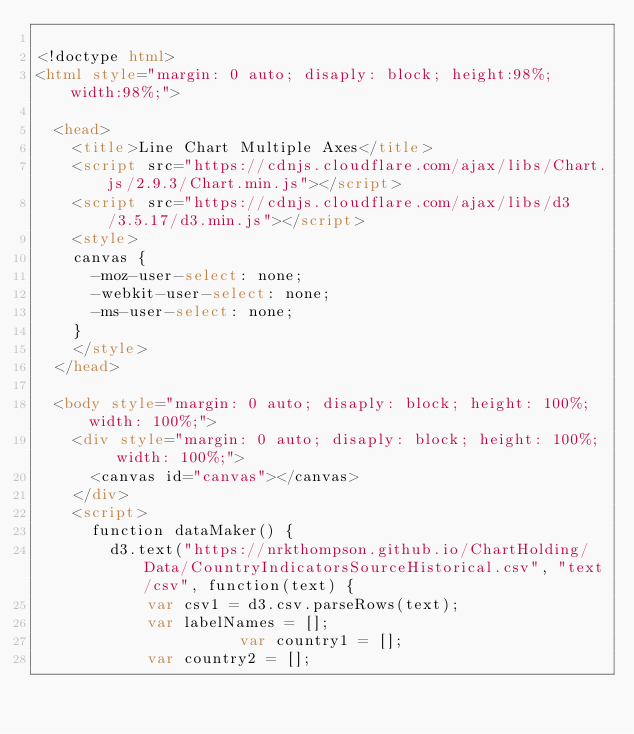<code> <loc_0><loc_0><loc_500><loc_500><_HTML_>
<!doctype html>
<html style="margin: 0 auto; disaply: block; height:98%;  width:98%;">

	<head>
		<title>Line Chart Multiple Axes</title>
		<script src="https://cdnjs.cloudflare.com/ajax/libs/Chart.js/2.9.3/Chart.min.js"></script>
		<script src="https://cdnjs.cloudflare.com/ajax/libs/d3/3.5.17/d3.min.js"></script>
		<style>
		canvas {
			-moz-user-select: none;
			-webkit-user-select: none;
			-ms-user-select: none;
		}
		</style>
	</head>

	<body style="margin: 0 auto; disaply: block; height: 100%;  width: 100%;">
		<div style="margin: 0 auto; disaply: block; height: 100%;  width: 100%;">
			<canvas id="canvas"></canvas>
		</div>
		<script>
			function dataMaker() {
				d3.text("https://nrkthompson.github.io/ChartHolding/Data/CountryIndicatorsSourceHistorical.csv", "text/csv", function(text) {
					  var csv1 = d3.csv.parseRows(text);
					  var labelNames = [];
            				  var country1 = [];
					  var country2 = [];</code> 